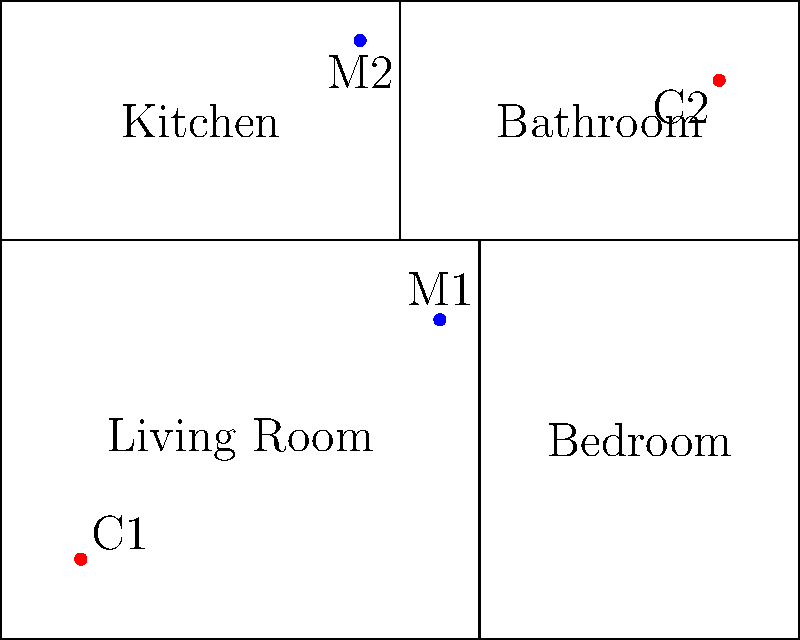In the floor plan shown, two cameras (C1 and C2) and two motion sensors (M1 and M2) are installed. If we consider the group of all possible combinations of these devices working or not working, how many subgroups of this group contain at least one working camera? Let's approach this step-by-step:

1) First, we need to understand what our group is. Each device can be either working (1) or not working (0). So, we have 4 devices, each with 2 states. This gives us a total of $2^4 = 16$ possible combinations.

2) These 16 combinations form a group under the operation of component-wise XOR (exclusive or). This group is isomorphic to $(\mathbb{Z}_2)^4$.

3) Now, we need to count the subgroups that contain at least one working camera. Let's break this down:

   a) Subgroups with C1 working: There are $2^3 = 8$ such subgroups (as the other 3 devices can be in any state).
   b) Subgroups with C2 working: Again, there are 8 such subgroups.
   c) However, we've double-counted the subgroups where both cameras are working. We need to subtract these. There are $2^2 = 4$ such subgroups.

4) Therefore, the total number of subgroups with at least one working camera is:
   $8 + 8 - 4 = 12$

5) We can verify this by noting that the only subgroups we haven't counted are those where both cameras are off, of which there are $2^2 = 4$. And indeed, $12 + 4 = 16$, which is the total number of subgroups.
Answer: 12 subgroups 